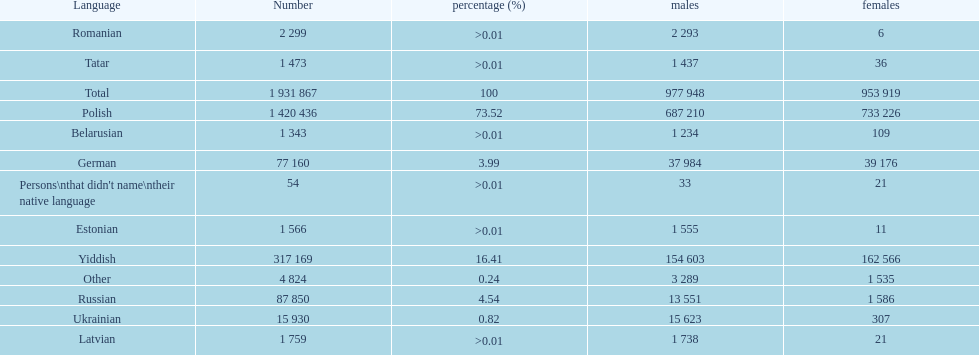Number of male russian speakers 13 551. 